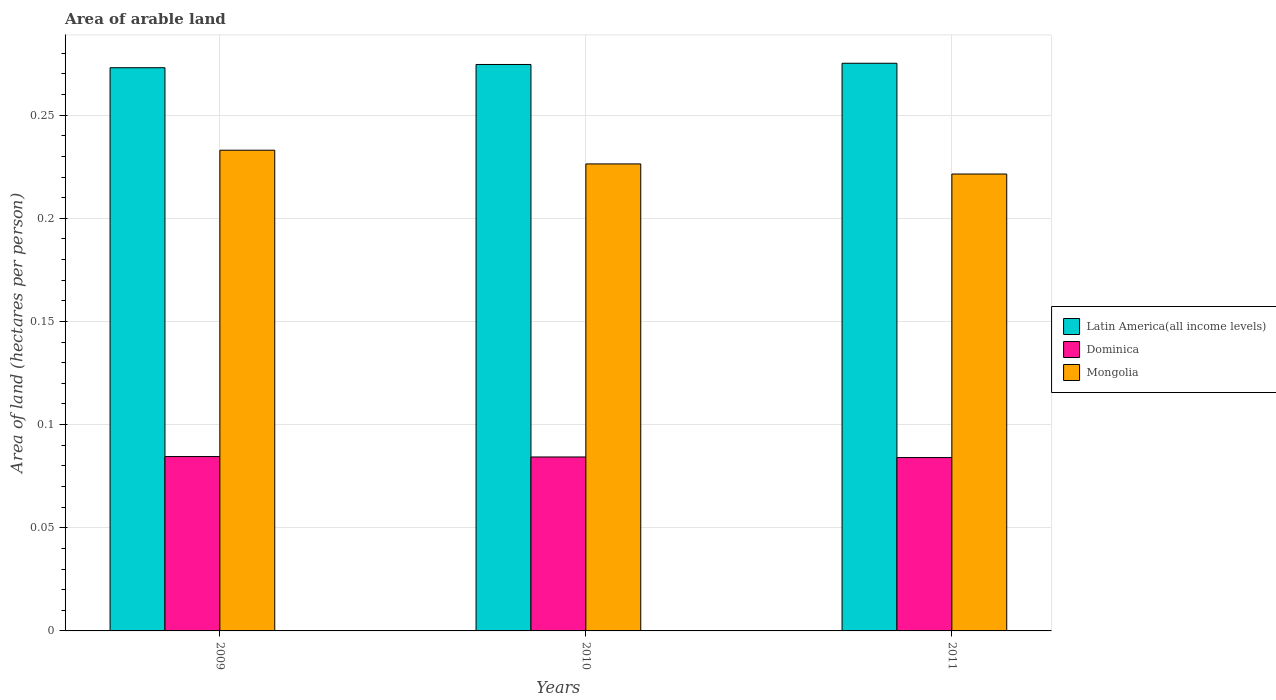How many different coloured bars are there?
Make the answer very short. 3. How many groups of bars are there?
Make the answer very short. 3. Are the number of bars per tick equal to the number of legend labels?
Make the answer very short. Yes. Are the number of bars on each tick of the X-axis equal?
Your answer should be compact. Yes. What is the label of the 3rd group of bars from the left?
Your answer should be very brief. 2011. In how many cases, is the number of bars for a given year not equal to the number of legend labels?
Your answer should be very brief. 0. What is the total arable land in Dominica in 2011?
Ensure brevity in your answer.  0.08. Across all years, what is the maximum total arable land in Dominica?
Provide a short and direct response. 0.08. Across all years, what is the minimum total arable land in Mongolia?
Give a very brief answer. 0.22. In which year was the total arable land in Mongolia maximum?
Your answer should be very brief. 2009. What is the total total arable land in Latin America(all income levels) in the graph?
Offer a terse response. 0.82. What is the difference between the total arable land in Dominica in 2009 and that in 2010?
Your answer should be very brief. 0. What is the difference between the total arable land in Dominica in 2011 and the total arable land in Mongolia in 2010?
Offer a very short reply. -0.14. What is the average total arable land in Latin America(all income levels) per year?
Offer a terse response. 0.27. In the year 2009, what is the difference between the total arable land in Latin America(all income levels) and total arable land in Mongolia?
Your answer should be compact. 0.04. In how many years, is the total arable land in Dominica greater than 0.02 hectares per person?
Your answer should be very brief. 3. What is the ratio of the total arable land in Dominica in 2010 to that in 2011?
Ensure brevity in your answer.  1. What is the difference between the highest and the second highest total arable land in Dominica?
Provide a short and direct response. 0. What is the difference between the highest and the lowest total arable land in Latin America(all income levels)?
Offer a terse response. 0. Is the sum of the total arable land in Latin America(all income levels) in 2010 and 2011 greater than the maximum total arable land in Mongolia across all years?
Give a very brief answer. Yes. What does the 2nd bar from the left in 2011 represents?
Give a very brief answer. Dominica. What does the 2nd bar from the right in 2011 represents?
Provide a short and direct response. Dominica. Is it the case that in every year, the sum of the total arable land in Latin America(all income levels) and total arable land in Dominica is greater than the total arable land in Mongolia?
Provide a succinct answer. Yes. Are all the bars in the graph horizontal?
Your answer should be very brief. No. How many years are there in the graph?
Ensure brevity in your answer.  3. What is the title of the graph?
Your response must be concise. Area of arable land. Does "Eritrea" appear as one of the legend labels in the graph?
Offer a terse response. No. What is the label or title of the Y-axis?
Ensure brevity in your answer.  Area of land (hectares per person). What is the Area of land (hectares per person) in Latin America(all income levels) in 2009?
Your response must be concise. 0.27. What is the Area of land (hectares per person) in Dominica in 2009?
Make the answer very short. 0.08. What is the Area of land (hectares per person) of Mongolia in 2009?
Keep it short and to the point. 0.23. What is the Area of land (hectares per person) in Latin America(all income levels) in 2010?
Provide a short and direct response. 0.27. What is the Area of land (hectares per person) of Dominica in 2010?
Give a very brief answer. 0.08. What is the Area of land (hectares per person) of Mongolia in 2010?
Keep it short and to the point. 0.23. What is the Area of land (hectares per person) in Latin America(all income levels) in 2011?
Give a very brief answer. 0.28. What is the Area of land (hectares per person) in Dominica in 2011?
Your response must be concise. 0.08. What is the Area of land (hectares per person) in Mongolia in 2011?
Your response must be concise. 0.22. Across all years, what is the maximum Area of land (hectares per person) of Latin America(all income levels)?
Keep it short and to the point. 0.28. Across all years, what is the maximum Area of land (hectares per person) of Dominica?
Keep it short and to the point. 0.08. Across all years, what is the maximum Area of land (hectares per person) of Mongolia?
Your answer should be very brief. 0.23. Across all years, what is the minimum Area of land (hectares per person) of Latin America(all income levels)?
Provide a succinct answer. 0.27. Across all years, what is the minimum Area of land (hectares per person) of Dominica?
Provide a short and direct response. 0.08. Across all years, what is the minimum Area of land (hectares per person) of Mongolia?
Ensure brevity in your answer.  0.22. What is the total Area of land (hectares per person) of Latin America(all income levels) in the graph?
Make the answer very short. 0.82. What is the total Area of land (hectares per person) in Dominica in the graph?
Offer a very short reply. 0.25. What is the total Area of land (hectares per person) of Mongolia in the graph?
Your answer should be compact. 0.68. What is the difference between the Area of land (hectares per person) of Latin America(all income levels) in 2009 and that in 2010?
Your answer should be very brief. -0. What is the difference between the Area of land (hectares per person) of Dominica in 2009 and that in 2010?
Your response must be concise. 0. What is the difference between the Area of land (hectares per person) in Mongolia in 2009 and that in 2010?
Provide a short and direct response. 0.01. What is the difference between the Area of land (hectares per person) in Latin America(all income levels) in 2009 and that in 2011?
Make the answer very short. -0. What is the difference between the Area of land (hectares per person) of Dominica in 2009 and that in 2011?
Your response must be concise. 0. What is the difference between the Area of land (hectares per person) in Mongolia in 2009 and that in 2011?
Your answer should be compact. 0.01. What is the difference between the Area of land (hectares per person) of Latin America(all income levels) in 2010 and that in 2011?
Make the answer very short. -0. What is the difference between the Area of land (hectares per person) of Dominica in 2010 and that in 2011?
Provide a short and direct response. 0. What is the difference between the Area of land (hectares per person) of Mongolia in 2010 and that in 2011?
Ensure brevity in your answer.  0. What is the difference between the Area of land (hectares per person) of Latin America(all income levels) in 2009 and the Area of land (hectares per person) of Dominica in 2010?
Offer a terse response. 0.19. What is the difference between the Area of land (hectares per person) in Latin America(all income levels) in 2009 and the Area of land (hectares per person) in Mongolia in 2010?
Give a very brief answer. 0.05. What is the difference between the Area of land (hectares per person) in Dominica in 2009 and the Area of land (hectares per person) in Mongolia in 2010?
Keep it short and to the point. -0.14. What is the difference between the Area of land (hectares per person) in Latin America(all income levels) in 2009 and the Area of land (hectares per person) in Dominica in 2011?
Your answer should be very brief. 0.19. What is the difference between the Area of land (hectares per person) in Latin America(all income levels) in 2009 and the Area of land (hectares per person) in Mongolia in 2011?
Provide a succinct answer. 0.05. What is the difference between the Area of land (hectares per person) of Dominica in 2009 and the Area of land (hectares per person) of Mongolia in 2011?
Make the answer very short. -0.14. What is the difference between the Area of land (hectares per person) of Latin America(all income levels) in 2010 and the Area of land (hectares per person) of Dominica in 2011?
Offer a very short reply. 0.19. What is the difference between the Area of land (hectares per person) in Latin America(all income levels) in 2010 and the Area of land (hectares per person) in Mongolia in 2011?
Your answer should be compact. 0.05. What is the difference between the Area of land (hectares per person) in Dominica in 2010 and the Area of land (hectares per person) in Mongolia in 2011?
Provide a short and direct response. -0.14. What is the average Area of land (hectares per person) in Latin America(all income levels) per year?
Provide a succinct answer. 0.27. What is the average Area of land (hectares per person) in Dominica per year?
Keep it short and to the point. 0.08. What is the average Area of land (hectares per person) of Mongolia per year?
Provide a short and direct response. 0.23. In the year 2009, what is the difference between the Area of land (hectares per person) of Latin America(all income levels) and Area of land (hectares per person) of Dominica?
Ensure brevity in your answer.  0.19. In the year 2009, what is the difference between the Area of land (hectares per person) of Latin America(all income levels) and Area of land (hectares per person) of Mongolia?
Give a very brief answer. 0.04. In the year 2009, what is the difference between the Area of land (hectares per person) in Dominica and Area of land (hectares per person) in Mongolia?
Provide a succinct answer. -0.15. In the year 2010, what is the difference between the Area of land (hectares per person) of Latin America(all income levels) and Area of land (hectares per person) of Dominica?
Offer a terse response. 0.19. In the year 2010, what is the difference between the Area of land (hectares per person) in Latin America(all income levels) and Area of land (hectares per person) in Mongolia?
Your response must be concise. 0.05. In the year 2010, what is the difference between the Area of land (hectares per person) of Dominica and Area of land (hectares per person) of Mongolia?
Make the answer very short. -0.14. In the year 2011, what is the difference between the Area of land (hectares per person) of Latin America(all income levels) and Area of land (hectares per person) of Dominica?
Provide a succinct answer. 0.19. In the year 2011, what is the difference between the Area of land (hectares per person) of Latin America(all income levels) and Area of land (hectares per person) of Mongolia?
Provide a short and direct response. 0.05. In the year 2011, what is the difference between the Area of land (hectares per person) in Dominica and Area of land (hectares per person) in Mongolia?
Give a very brief answer. -0.14. What is the ratio of the Area of land (hectares per person) of Latin America(all income levels) in 2009 to that in 2010?
Give a very brief answer. 0.99. What is the ratio of the Area of land (hectares per person) in Dominica in 2009 to that in 2010?
Ensure brevity in your answer.  1. What is the ratio of the Area of land (hectares per person) in Mongolia in 2009 to that in 2010?
Your response must be concise. 1.03. What is the ratio of the Area of land (hectares per person) of Latin America(all income levels) in 2009 to that in 2011?
Ensure brevity in your answer.  0.99. What is the ratio of the Area of land (hectares per person) in Mongolia in 2009 to that in 2011?
Offer a very short reply. 1.05. What is the ratio of the Area of land (hectares per person) in Latin America(all income levels) in 2010 to that in 2011?
Your response must be concise. 1. What is the ratio of the Area of land (hectares per person) in Mongolia in 2010 to that in 2011?
Your answer should be very brief. 1.02. What is the difference between the highest and the second highest Area of land (hectares per person) in Latin America(all income levels)?
Keep it short and to the point. 0. What is the difference between the highest and the second highest Area of land (hectares per person) of Mongolia?
Offer a very short reply. 0.01. What is the difference between the highest and the lowest Area of land (hectares per person) in Latin America(all income levels)?
Your answer should be compact. 0. What is the difference between the highest and the lowest Area of land (hectares per person) of Mongolia?
Offer a very short reply. 0.01. 